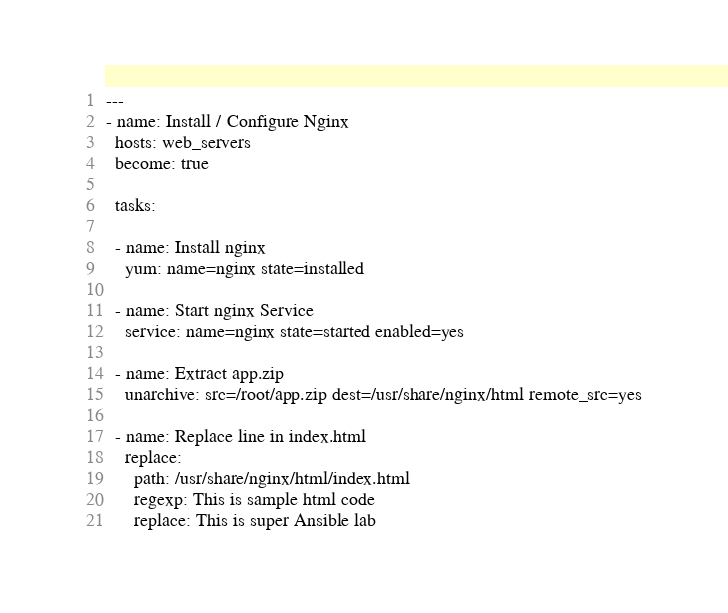<code> <loc_0><loc_0><loc_500><loc_500><_YAML_>---
- name: Install / Configure Nginx
  hosts: web_servers
  become: true

  tasks:

  - name: Install nginx
    yum: name=nginx state=installed

  - name: Start nginx Service
    service: name=nginx state=started enabled=yes

  - name: Extract app.zip
    unarchive: src=/root/app.zip dest=/usr/share/nginx/html remote_src=yes

  - name: Replace line in index.html
    replace:
      path: /usr/share/nginx/html/index.html
      regexp: This is sample html code
      replace: This is super Ansible lab</code> 